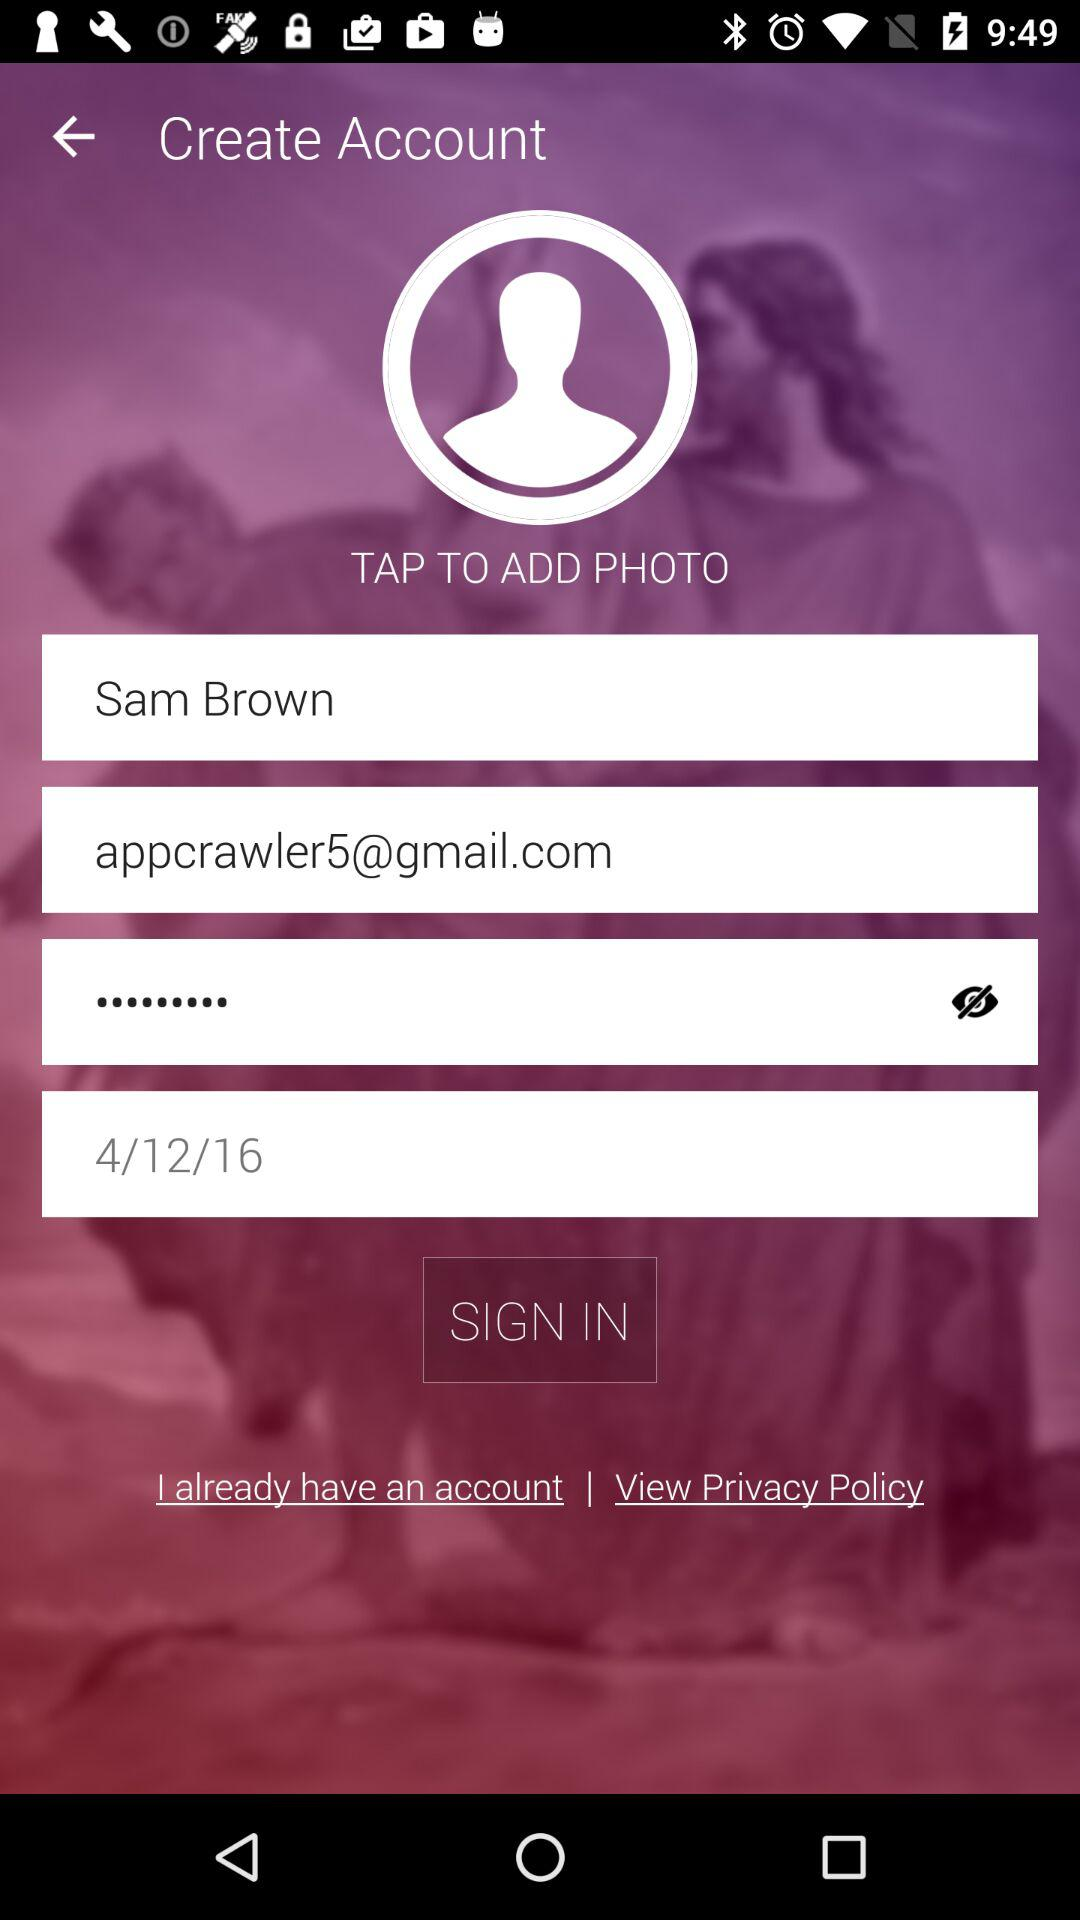What is the date? The date is April 12, 2016. 